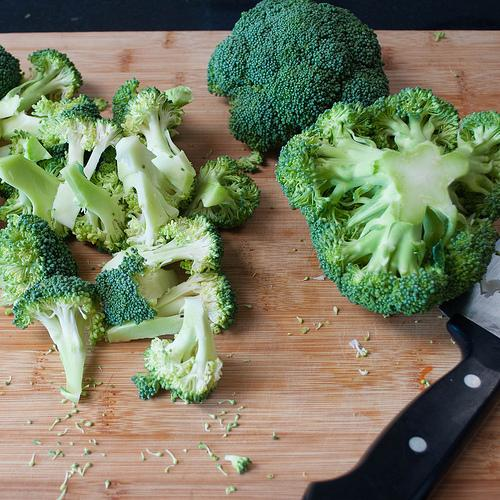What is the overall quality of the image considering the details and objects present? The overall image quality is high, as it captures various detailed objects, including broccoli, cutting board, and knife. What distinguishes the knife handle in terms of its design elements? The knife handle is black, featuring two gray dots and a silver bolt. Provide a concise description of the overall sentiment of the image. A neutral, everyday scene of fresh broccoli being chopped on a wooden cutting board using a knife with a black handle. How many times does the phrase "chopped fresh broccoli stem" appear in the object captions? The phrase "chopped fresh broccoli stem" appears 8 times. How would you describe the broccoli pieces on the wooden cutting board? There are chopped fresh broccoli stems and heads in various shades of green, along with tiny pieces and debris. What utensil is being used near the broccoli in the image? A knife with a black handle and silver blade. What are the dimensions of the wooden cutting board in the image? The wooden cutting board has a width of 495 and a height of 495. Identify the main objects in the image and their primary colors. Pieces of broccoli (green), wooden cutting board (brown), knife with black handle and silver blade, and a black table. What is the object interacting with the knife in the image? The knife interacts with the chopped up pieces of broccoli. 